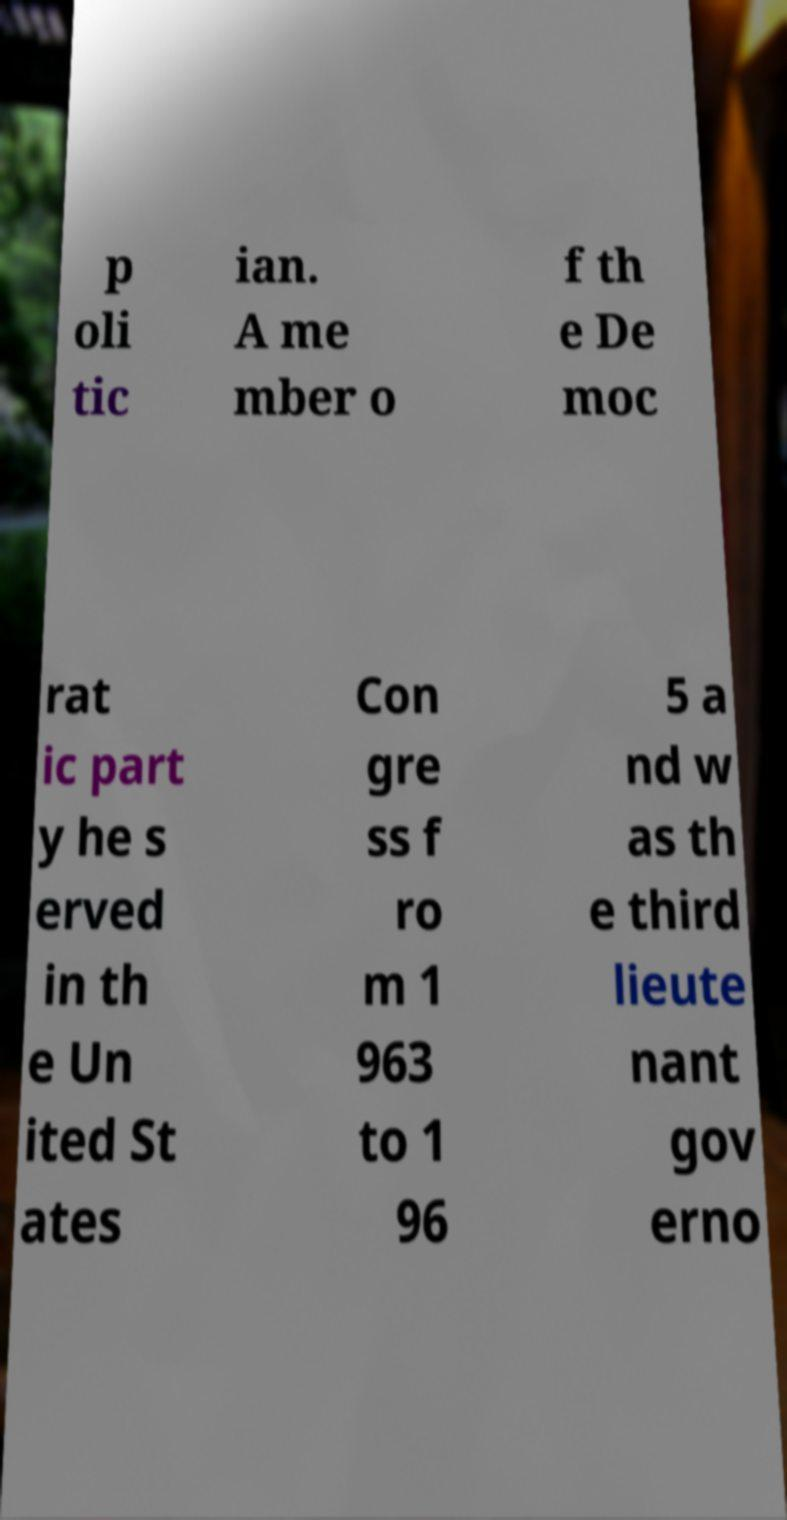Please read and relay the text visible in this image. What does it say? p oli tic ian. A me mber o f th e De moc rat ic part y he s erved in th e Un ited St ates Con gre ss f ro m 1 963 to 1 96 5 a nd w as th e third lieute nant gov erno 